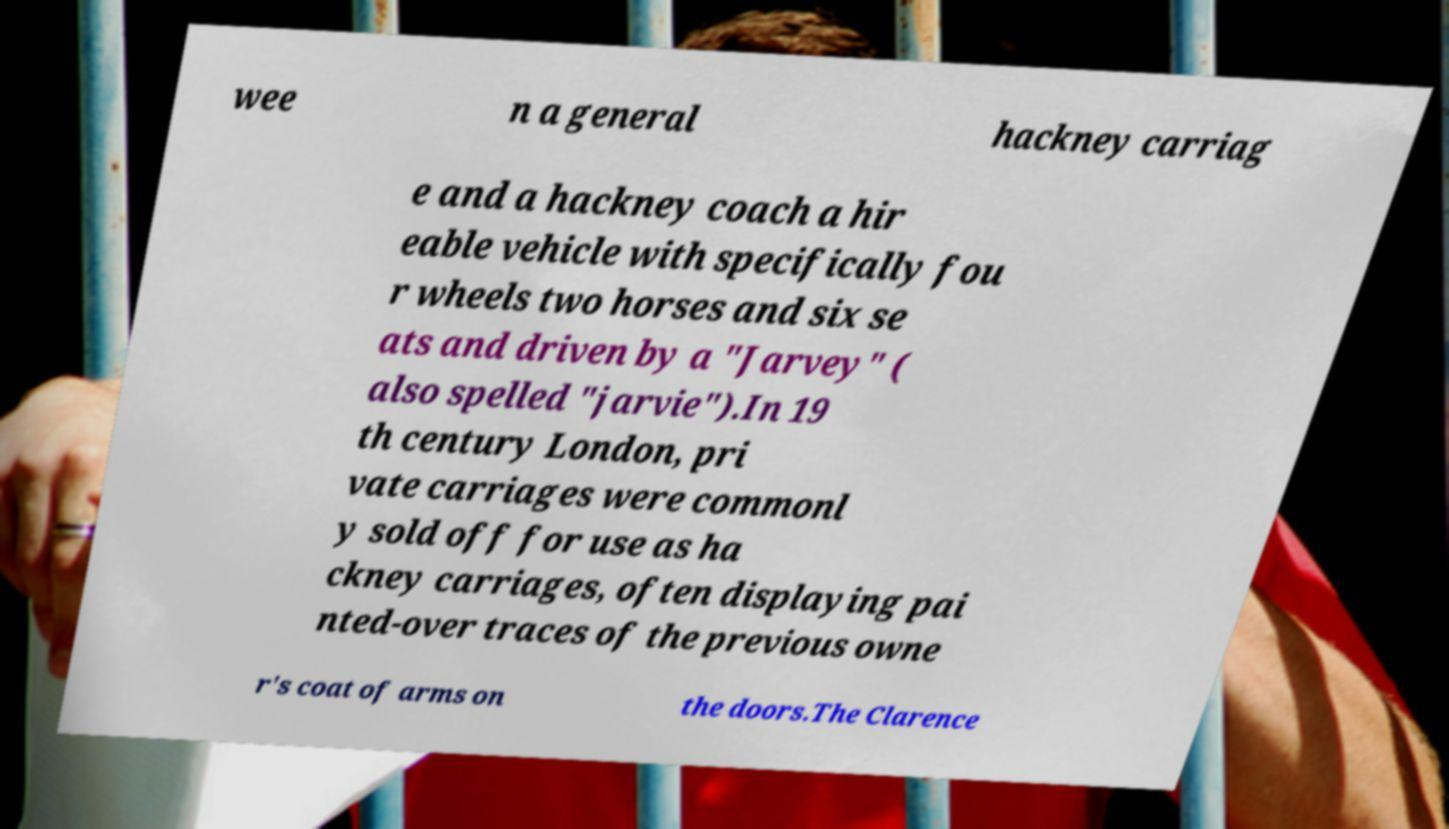Could you extract and type out the text from this image? wee n a general hackney carriag e and a hackney coach a hir eable vehicle with specifically fou r wheels two horses and six se ats and driven by a "Jarvey" ( also spelled "jarvie").In 19 th century London, pri vate carriages were commonl y sold off for use as ha ckney carriages, often displaying pai nted-over traces of the previous owne r's coat of arms on the doors.The Clarence 